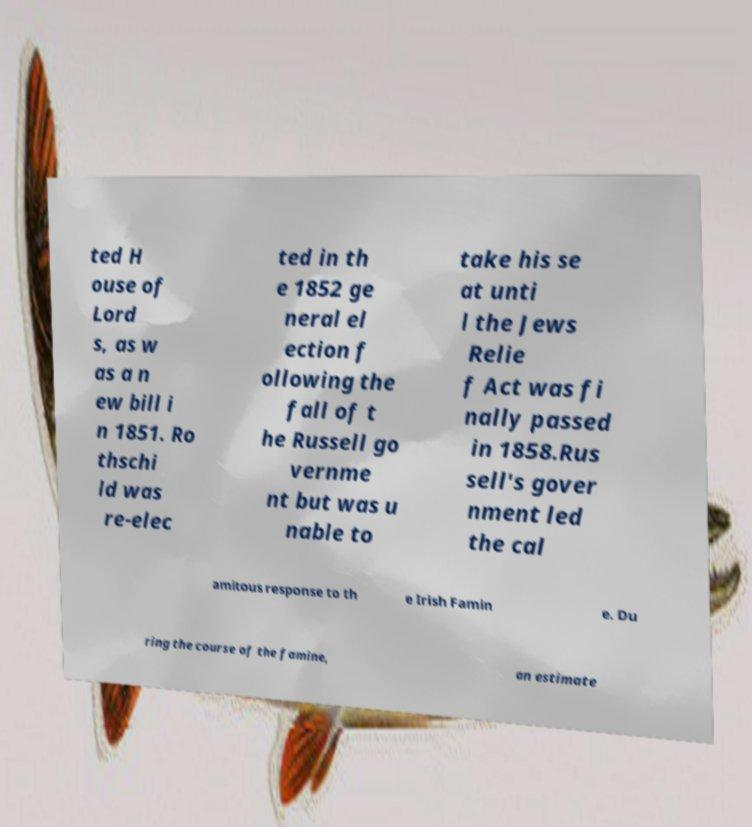For documentation purposes, I need the text within this image transcribed. Could you provide that? ted H ouse of Lord s, as w as a n ew bill i n 1851. Ro thschi ld was re-elec ted in th e 1852 ge neral el ection f ollowing the fall of t he Russell go vernme nt but was u nable to take his se at unti l the Jews Relie f Act was fi nally passed in 1858.Rus sell's gover nment led the cal amitous response to th e Irish Famin e. Du ring the course of the famine, an estimate 